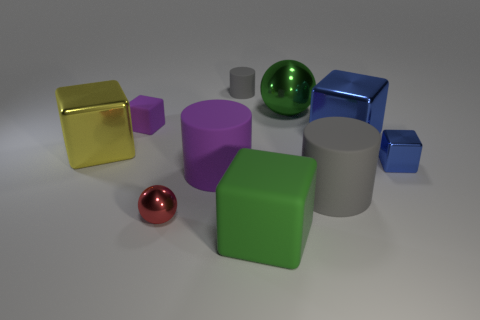There is a thing that is the same color as the large ball; what size is it?
Give a very brief answer. Large. What number of balls have the same color as the small matte cylinder?
Provide a short and direct response. 0. There is a shiny ball that is to the left of the small cylinder; how big is it?
Your response must be concise. Small. There is a small metallic thing that is right of the big shiny cube that is on the right side of the gray object that is in front of the small matte block; what shape is it?
Provide a succinct answer. Cube. There is a matte object that is behind the small blue shiny thing and to the right of the red object; what is its shape?
Provide a short and direct response. Cylinder. Is there a red matte cube that has the same size as the red object?
Your answer should be very brief. No. Is the shape of the gray matte object behind the big metallic ball the same as  the large purple rubber thing?
Offer a terse response. Yes. Is the tiny purple matte object the same shape as the tiny blue object?
Give a very brief answer. Yes. Are there any small purple things that have the same shape as the big gray thing?
Ensure brevity in your answer.  No. The green object behind the gray cylinder that is in front of the big blue object is what shape?
Your response must be concise. Sphere. 